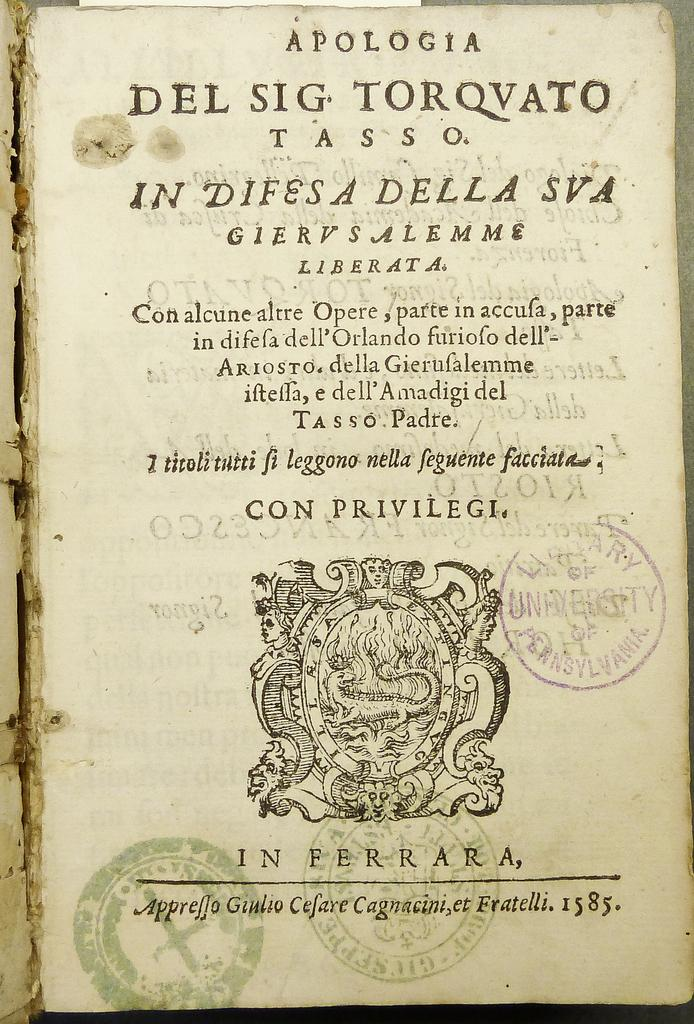What is present in the image that can be written on? There is a paper in the image that can be written on. What can be observed on the paper? Something is written on the paper, and there are stamps on it. What type of leaf is depicted on the paper in the image? There is no leaf depicted on the paper in the image. What disease is mentioned in the writing on the paper? There is no mention of a disease in the writing on the paper in the image. 